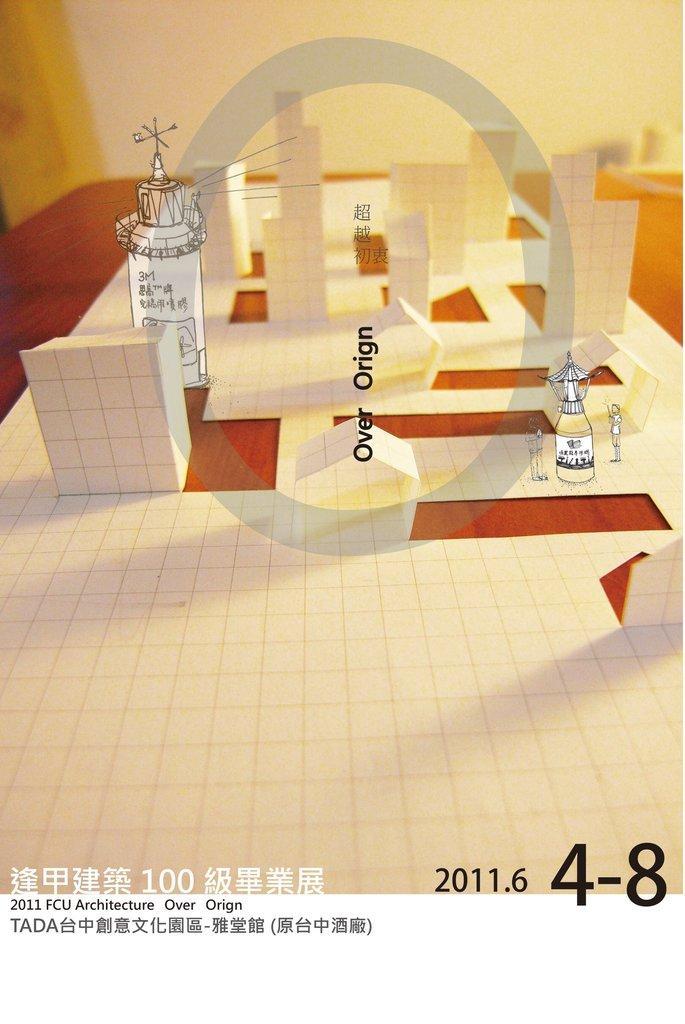How would you summarize this image in a sentence or two? In this image we can see some paper art which is placed on the table. We can also see some graphical effects and some text on it. 